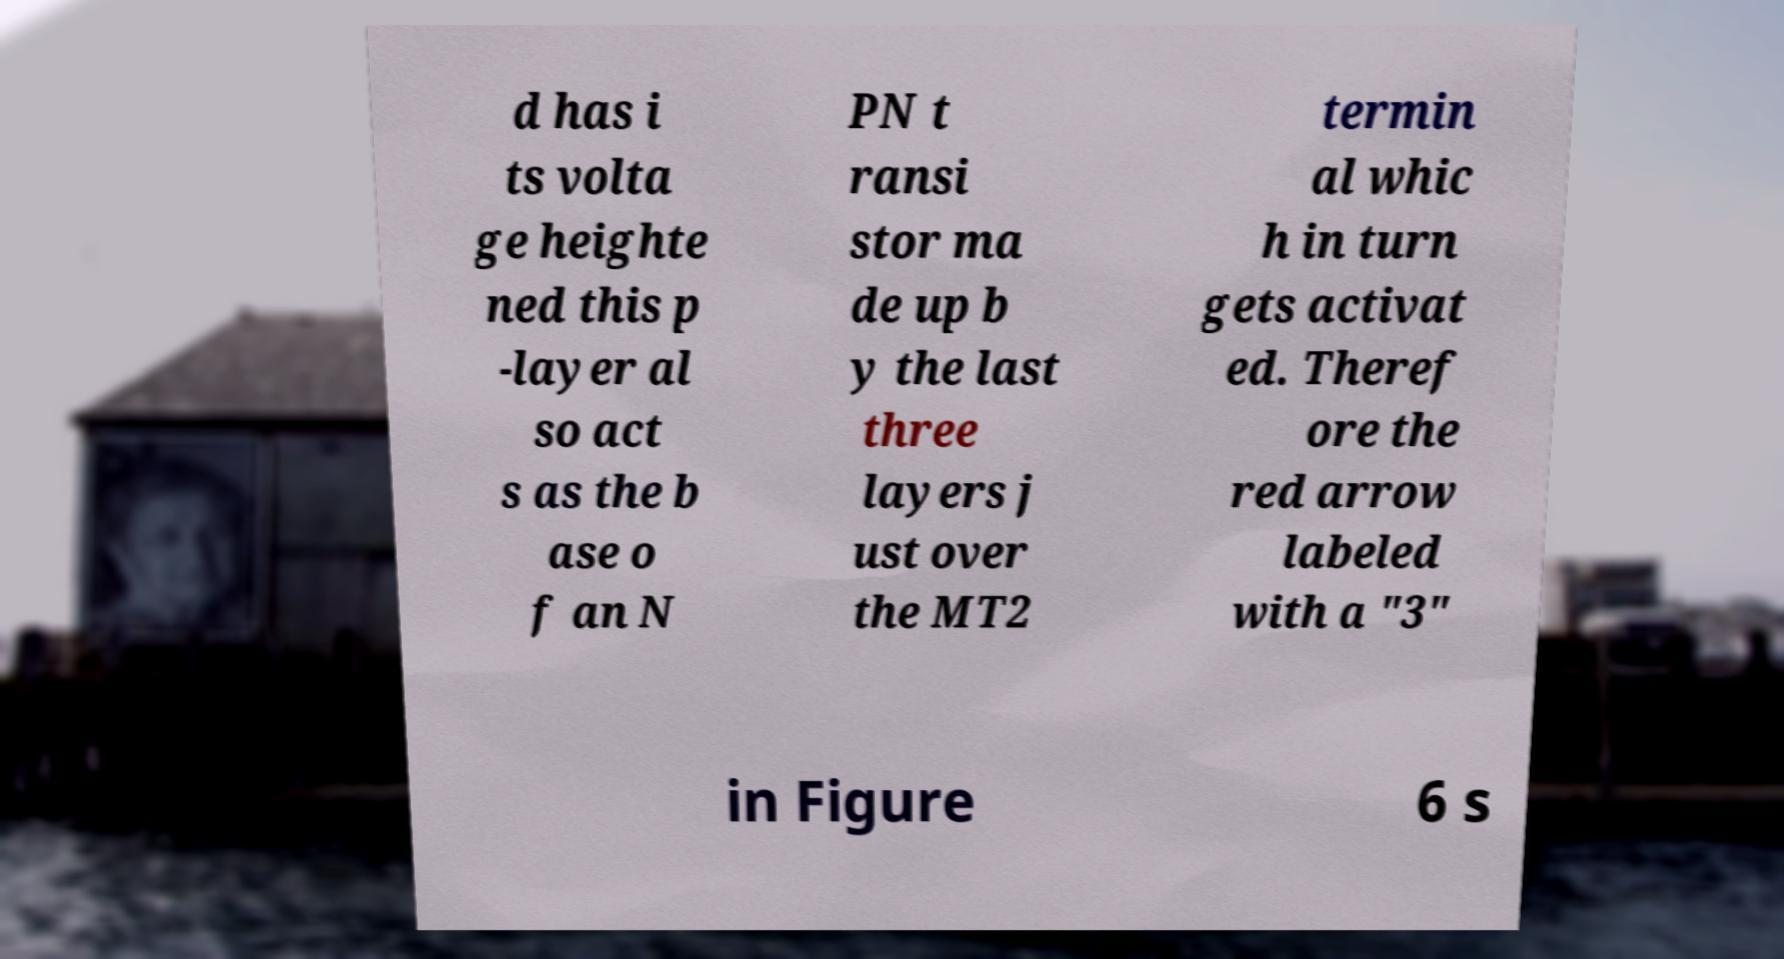Could you extract and type out the text from this image? d has i ts volta ge heighte ned this p -layer al so act s as the b ase o f an N PN t ransi stor ma de up b y the last three layers j ust over the MT2 termin al whic h in turn gets activat ed. Theref ore the red arrow labeled with a "3" in Figure 6 s 